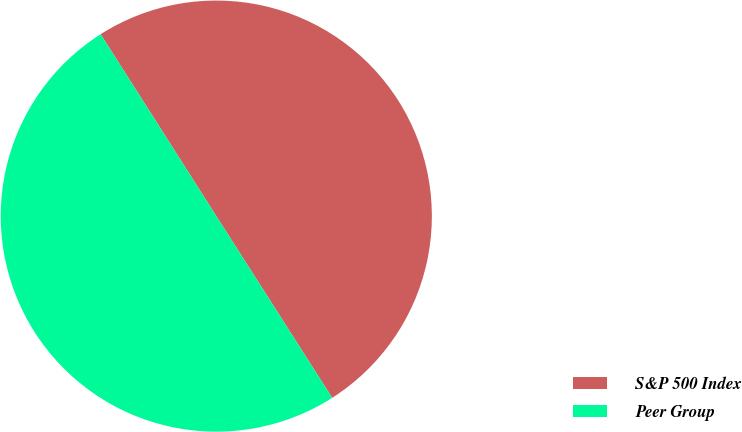<chart> <loc_0><loc_0><loc_500><loc_500><pie_chart><fcel>S&P 500 Index<fcel>Peer Group<nl><fcel>49.98%<fcel>50.02%<nl></chart> 